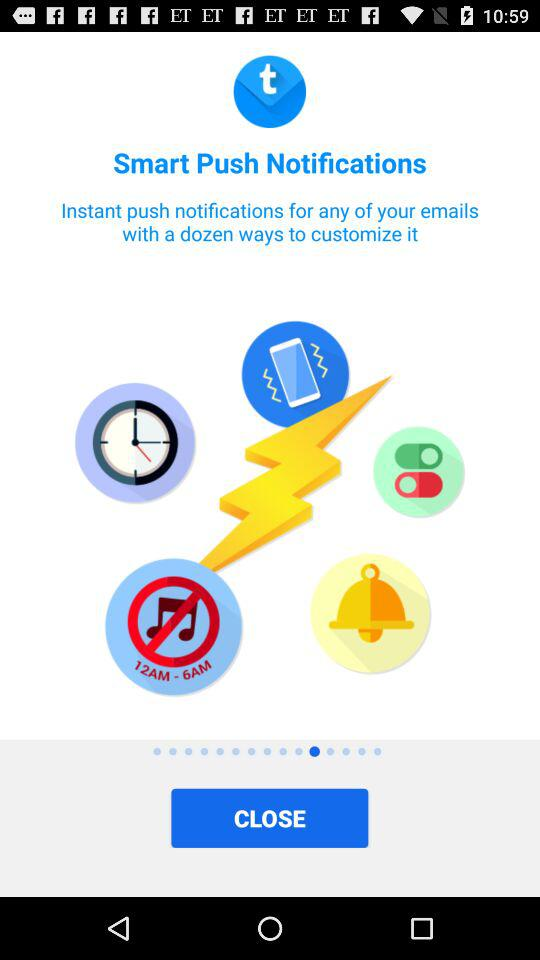What is the name of the application? The application name is Smart Push Notifications. 